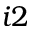<formula> <loc_0><loc_0><loc_500><loc_500>i 2</formula> 